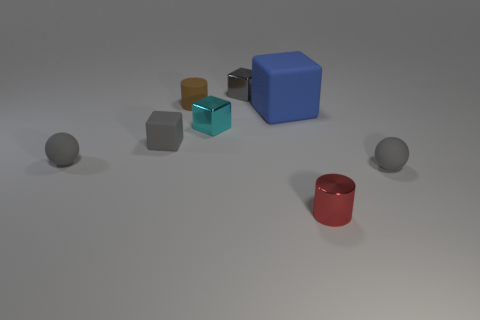Add 1 tiny rubber balls. How many objects exist? 9 Subtract all balls. How many objects are left? 6 Add 2 big rubber cylinders. How many big rubber cylinders exist? 2 Subtract 0 yellow cylinders. How many objects are left? 8 Subtract all small brown cylinders. Subtract all gray rubber blocks. How many objects are left? 6 Add 3 brown cylinders. How many brown cylinders are left? 4 